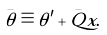Convert formula to latex. <formula><loc_0><loc_0><loc_500><loc_500>\bar { \theta } \equiv \theta ^ { \prime } + \bar { Q } x .</formula> 